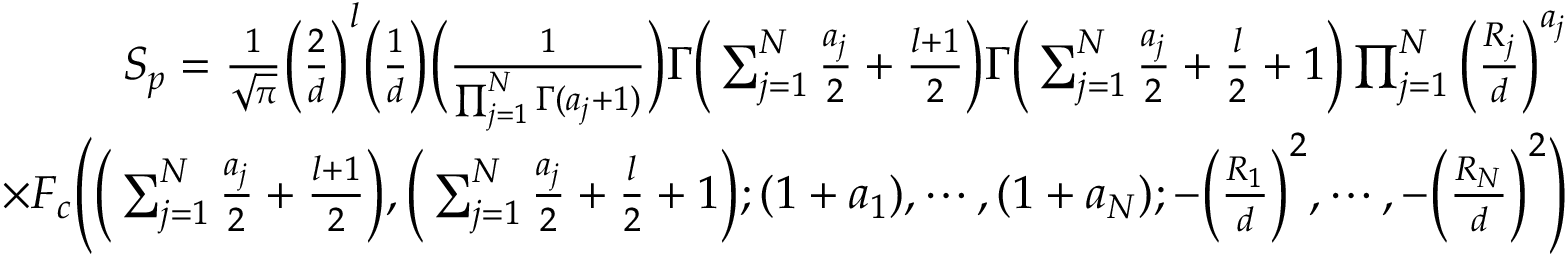Convert formula to latex. <formula><loc_0><loc_0><loc_500><loc_500>\begin{array} { r } { S _ { p } = \frac { 1 } { \sqrt { \pi } } \left ( \frac { 2 } { d } \right ) ^ { l } \left ( \frac { 1 } { d } \right ) \left ( \frac { 1 } { \prod _ { j = 1 } ^ { N } \Gamma ( a _ { j } + 1 ) } \right ) \Gamma \left ( \sum _ { j = 1 } ^ { N } \frac { a _ { j } } { 2 } + \frac { l + 1 } { 2 } \right ) \Gamma \left ( \sum _ { j = 1 } ^ { N } \frac { a _ { j } } { 2 } + \frac { l } { 2 } + 1 \right ) \prod _ { j = 1 } ^ { N } \left ( \frac { R _ { j } } { d } \right ) ^ { a _ { j } } } \\ { \times F _ { c } \left ( \left ( \sum _ { j = 1 } ^ { N } \frac { a _ { j } } { 2 } + \frac { l + 1 } { 2 } \right ) , \left ( \sum _ { j = 1 } ^ { N } \frac { a _ { j } } { 2 } + \frac { l } { 2 } + 1 \right ) ; ( 1 + a _ { 1 } ) , \cdots , ( 1 + a _ { N } ) ; - \left ( \frac { R _ { 1 } } { d } \right ) ^ { 2 } , \cdots , - \left ( \frac { R _ { N } } { d } \right ) ^ { 2 } \right ) } \end{array}</formula> 